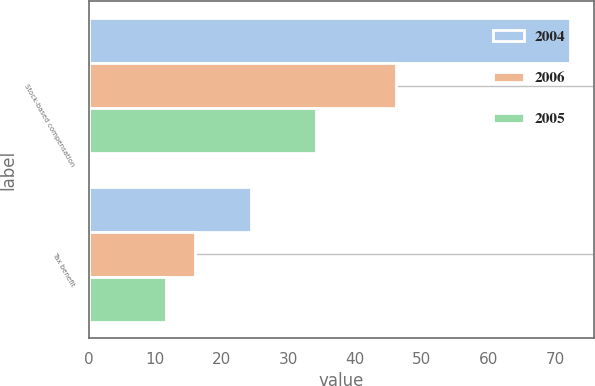<chart> <loc_0><loc_0><loc_500><loc_500><stacked_bar_chart><ecel><fcel>Stock-based compensation<fcel>Tax benefit<nl><fcel>2004<fcel>72.3<fcel>24.4<nl><fcel>2006<fcel>46.1<fcel>15.9<nl><fcel>2005<fcel>34.1<fcel>11.6<nl></chart> 